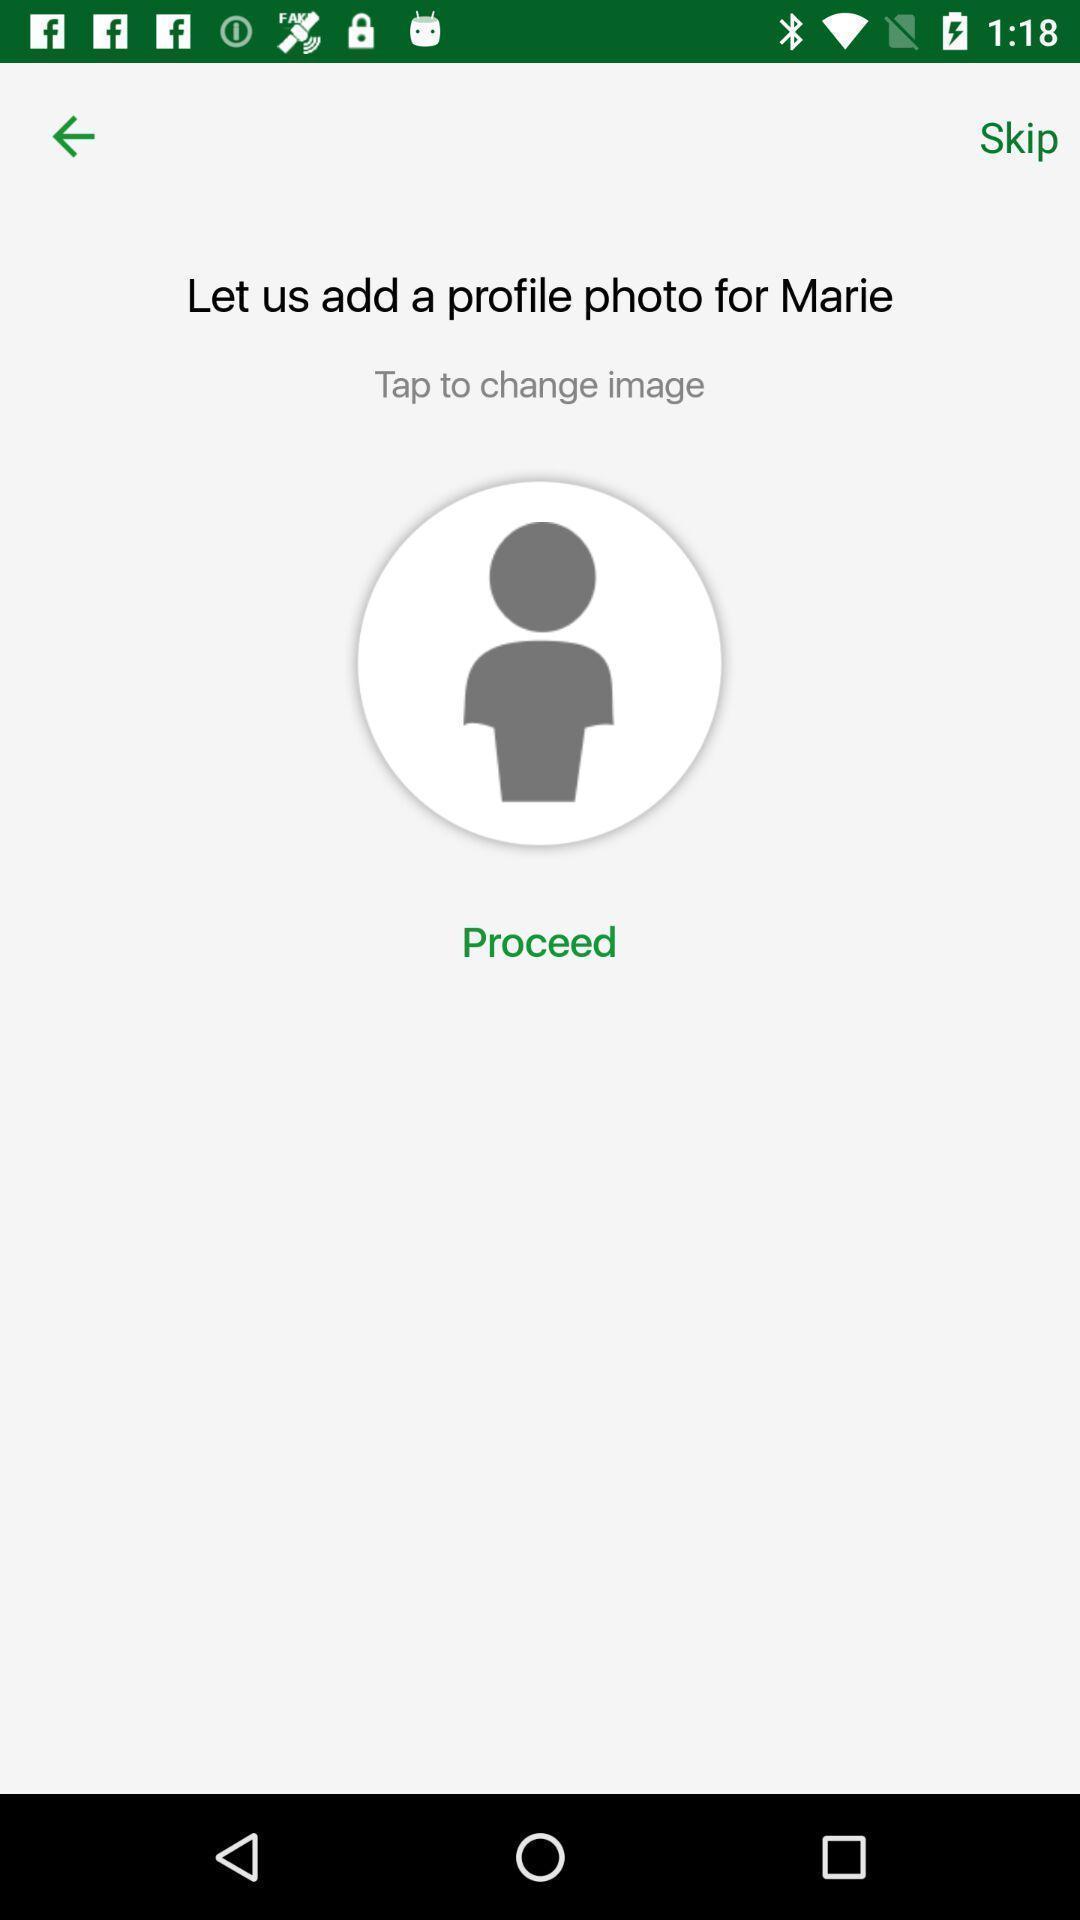Explain what's happening in this screen capture. Profile photo update in the application. 